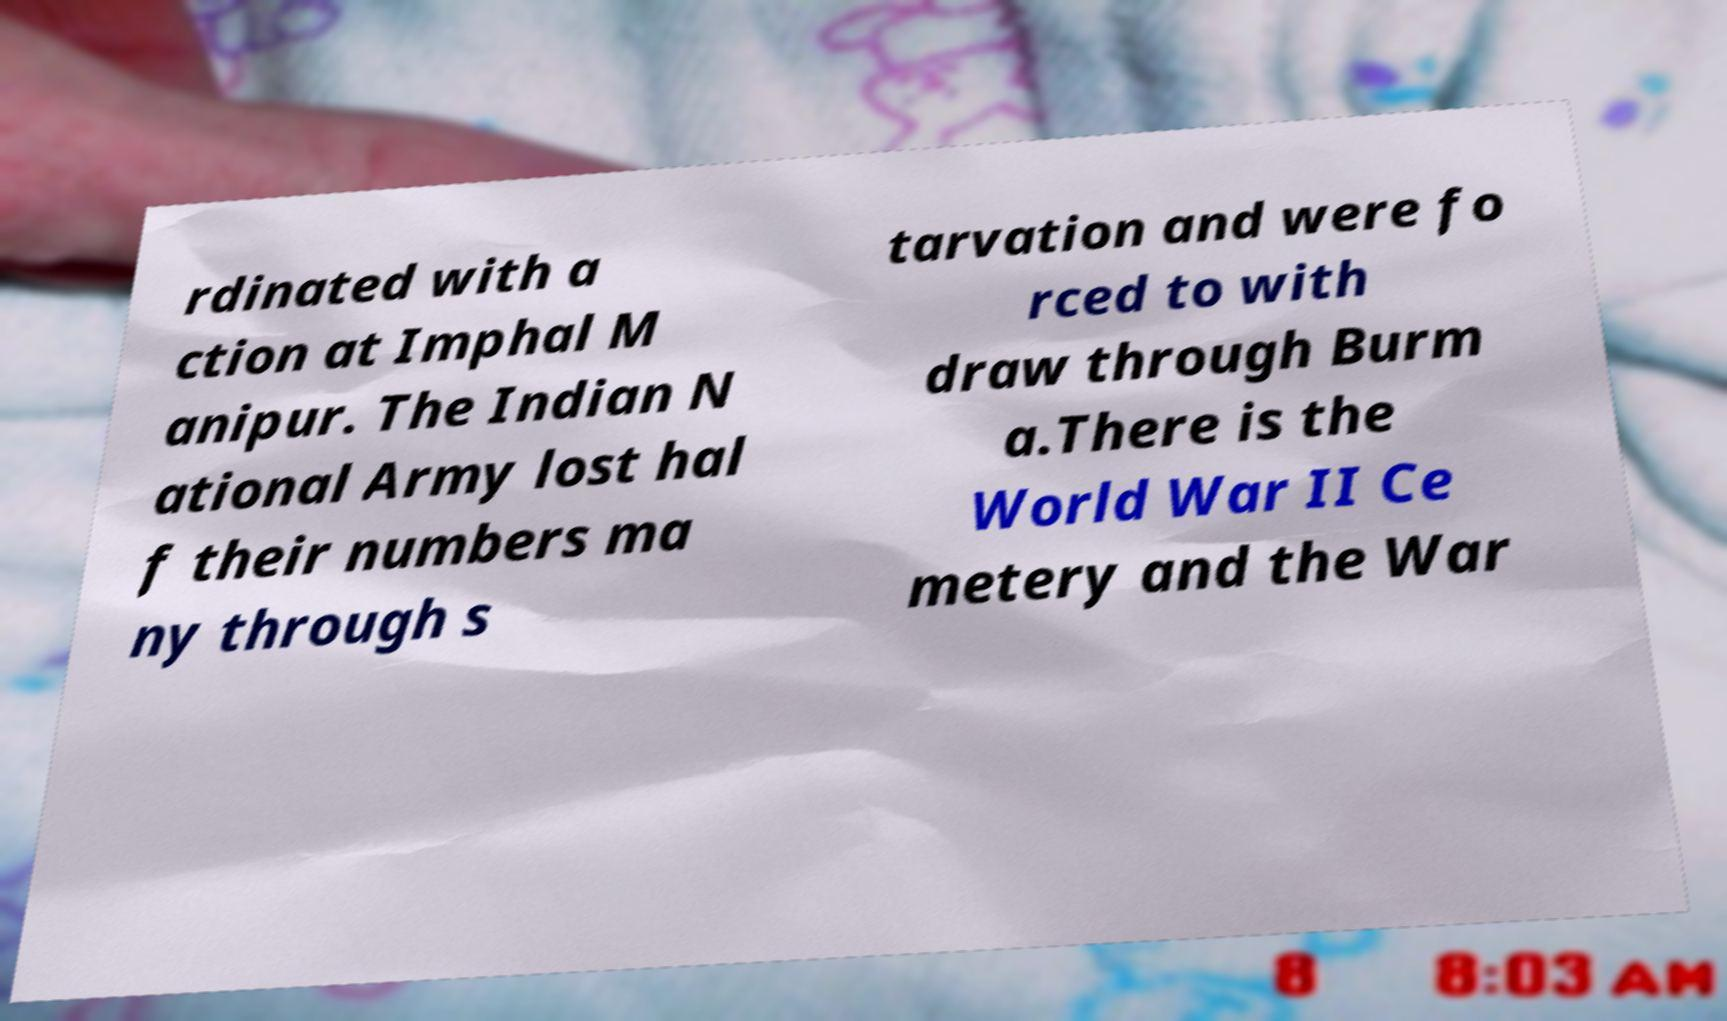There's text embedded in this image that I need extracted. Can you transcribe it verbatim? rdinated with a ction at Imphal M anipur. The Indian N ational Army lost hal f their numbers ma ny through s tarvation and were fo rced to with draw through Burm a.There is the World War II Ce metery and the War 